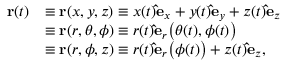<formula> <loc_0><loc_0><loc_500><loc_500>{ \begin{array} { r l } { r ( t ) } & { \equiv r ( x , y , z ) \equiv x ( t ) \hat { e } _ { x } + y ( t ) \hat { e } _ { y } + z ( t ) \hat { e } _ { z } } \\ & { \equiv r ( r , \theta , \phi ) \equiv r ( t ) \hat { e } _ { r } { \left ( } \theta ( t ) , \phi ( t ) { \right ) } } \\ & { \equiv r ( r , \phi , z ) \equiv r ( t ) \hat { e } _ { r } { \left ( } \phi ( t ) { \right ) } + z ( t ) \hat { e } _ { z } , } \end{array} }</formula> 